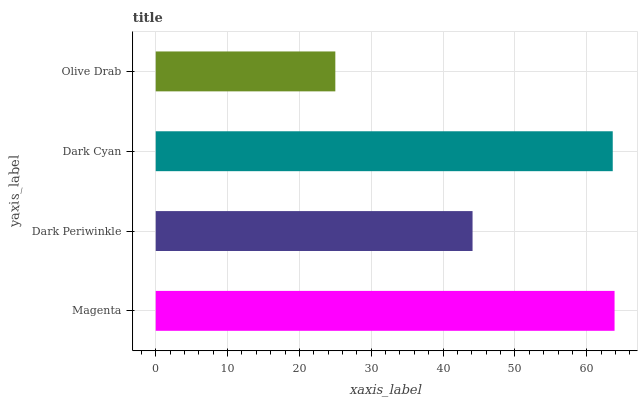Is Olive Drab the minimum?
Answer yes or no. Yes. Is Magenta the maximum?
Answer yes or no. Yes. Is Dark Periwinkle the minimum?
Answer yes or no. No. Is Dark Periwinkle the maximum?
Answer yes or no. No. Is Magenta greater than Dark Periwinkle?
Answer yes or no. Yes. Is Dark Periwinkle less than Magenta?
Answer yes or no. Yes. Is Dark Periwinkle greater than Magenta?
Answer yes or no. No. Is Magenta less than Dark Periwinkle?
Answer yes or no. No. Is Dark Cyan the high median?
Answer yes or no. Yes. Is Dark Periwinkle the low median?
Answer yes or no. Yes. Is Dark Periwinkle the high median?
Answer yes or no. No. Is Dark Cyan the low median?
Answer yes or no. No. 